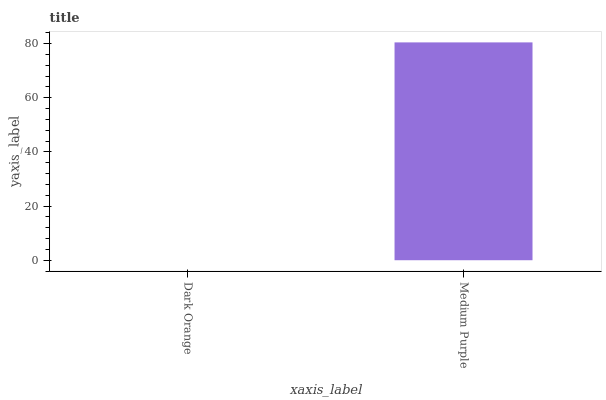Is Dark Orange the minimum?
Answer yes or no. Yes. Is Medium Purple the maximum?
Answer yes or no. Yes. Is Medium Purple the minimum?
Answer yes or no. No. Is Medium Purple greater than Dark Orange?
Answer yes or no. Yes. Is Dark Orange less than Medium Purple?
Answer yes or no. Yes. Is Dark Orange greater than Medium Purple?
Answer yes or no. No. Is Medium Purple less than Dark Orange?
Answer yes or no. No. Is Medium Purple the high median?
Answer yes or no. Yes. Is Dark Orange the low median?
Answer yes or no. Yes. Is Dark Orange the high median?
Answer yes or no. No. Is Medium Purple the low median?
Answer yes or no. No. 